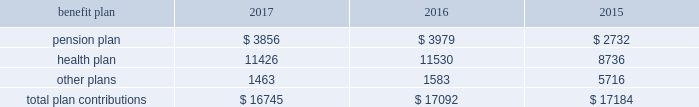112 / sl green realty corp .
2017 annual report 20 .
Commitments and contingencies legal proceedings as of december a031 , 2017 , the company and the operating partnership were not involved in any material litigation nor , to management 2019s knowledge , was any material litigation threat- ened against us or our portfolio which if adversely determined could have a material adverse impact on us .
Environmental matters our management believes that the properties are in compliance in all material respects with applicable federal , state and local ordinances and regulations regarding environmental issues .
Management is not aware of any environmental liability that it believes would have a materially adverse impact on our financial position , results of operations or cash flows .
Management is unaware of any instances in which it would incur significant envi- ronmental cost if any of our properties were sold .
Employment agreements we have entered into employment agreements with certain exec- utives , which expire between december a02018 and february a02020 .
The minimum cash-based compensation , including base sal- ary and guaranteed bonus payments , associated with these employment agreements total $ 5.4 a0million for 2018 .
In addition these employment agreements provide for deferred compen- sation awards based on our stock price and which were valued at $ 1.6 a0million on the grant date .
The value of these awards may change based on fluctuations in our stock price .
Insurance we maintain 201call-risk 201d property and rental value coverage ( includ- ing coverage regarding the perils of flood , earthquake and terrorism , excluding nuclear , biological , chemical , and radiological terrorism ( 201cnbcr 201d ) ) , within three property insurance programs and liability insurance .
Separate property and liability coverage may be purchased on a stand-alone basis for certain assets , such as the development of one vanderbilt .
Additionally , our captive insurance company , belmont insurance company , or belmont , pro- vides coverage for nbcr terrorist acts above a specified trigger , although if belmont is required to pay a claim under our insur- ance policies , we would ultimately record the loss to the extent of belmont 2019s required payment .
However , there is no assurance that in the future we will be able to procure coverage at a reasonable cost .
Further , if we experience losses that are uninsured or that exceed policy limits , we could lose the capital invested in the damaged properties as well as the anticipated future cash flows from those plan trustees adopted a rehabilitation plan consistent with this requirement .
No surcharges have been paid to the pension plan as of december a031 , 2017 .
For the pension plan years ended june a030 , 2017 , 2016 , and 2015 , the plan received contributions from employers totaling $ 257.8 a0million , $ 249.5 a0million , and $ 221.9 a0million .
Our contributions to the pension plan represent less than 5.0% ( 5.0 % ) of total contributions to the plan .
The health plan was established under the terms of collective bargaining agreements between the union , the realty advisory board on labor relations , inc .
And certain other employees .
The health plan provides health and other benefits to eligible participants employed in the building service industry who are covered under collective bargaining agreements , or other writ- ten agreements , with the union .
The health plan is administered by a board of trustees with equal representation by the employ- ers and the union and operates under employer identification number a013-2928869 .
The health plan receives contributions in accordance with collective bargaining agreements or participa- tion agreements .
Generally , these agreements provide that the employers contribute to the health plan at a fixed rate on behalf of each covered employee .
For the health plan years ended , june a030 , 2017 , 2016 , and 2015 , the plan received contributions from employers totaling $ 1.3 a0billion , $ 1.2 a0billion and $ 1.1 a0billion , respectively .
Our contributions to the health plan represent less than 5.0% ( 5.0 % ) of total contributions to the plan .
Contributions we made to the multi-employer plans for the years ended december a031 , 2017 , 2016 and 2015 are included in the table below ( in thousands ) : .
401 ( k ) plan in august a01997 , we implemented a 401 ( k ) a0savings/retirement plan , or the 401 ( k ) a0plan , to cover eligible employees of ours , and any designated affiliate .
The 401 ( k ) a0plan permits eligible employees to defer up to 15% ( 15 % ) of their annual compensation , subject to certain limitations imposed by the code .
The employees 2019 elective deferrals are immediately vested and non-forfeitable upon contribution to the 401 ( k ) a0plan .
During a02003 , we amended our 401 ( k ) a0plan to pro- vide for discretionary matching contributions only .
For 2017 , 2016 and 2015 , a matching contribution equal to 50% ( 50 % ) of the first 6% ( 6 % ) of annual compensation was made .
For the year ended december a031 , 2017 , we made a matching contribution of $ 728782 .
For the years ended december a031 , 2016 and 2015 , we made matching contribu- tions of $ 566000 and $ 550000 , respectively. .
What were the greatest health plan contributions in thousands? 
Computations: table_max(health plan, none)
Answer: 11530.0. 